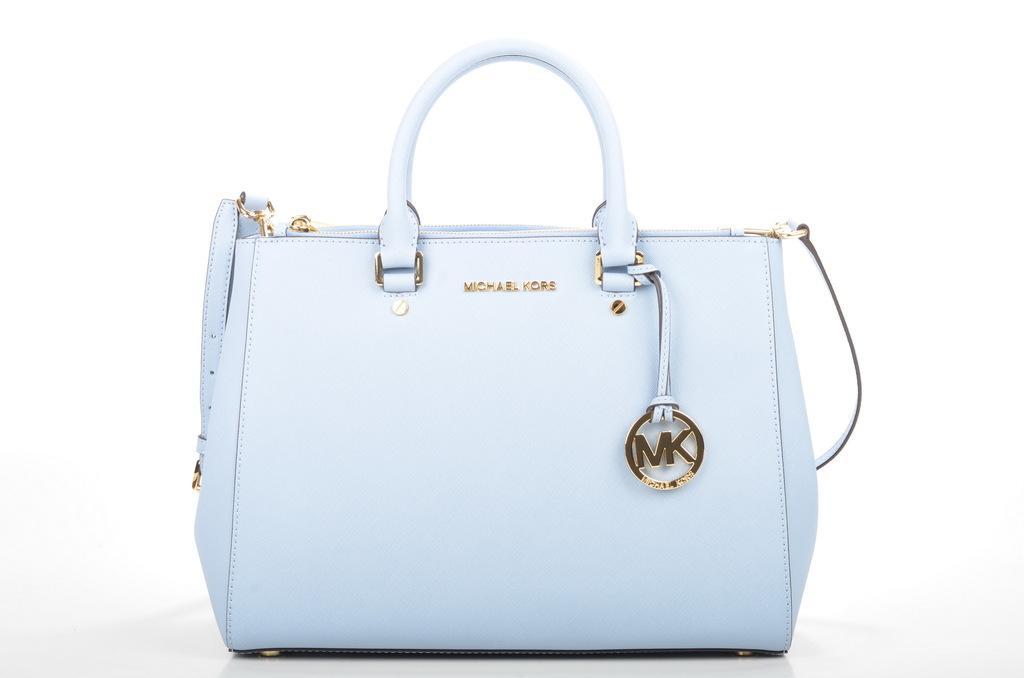Could you give a brief overview of what you see in this image? This is the picture of a blue back. Behind the bag is in white color. 